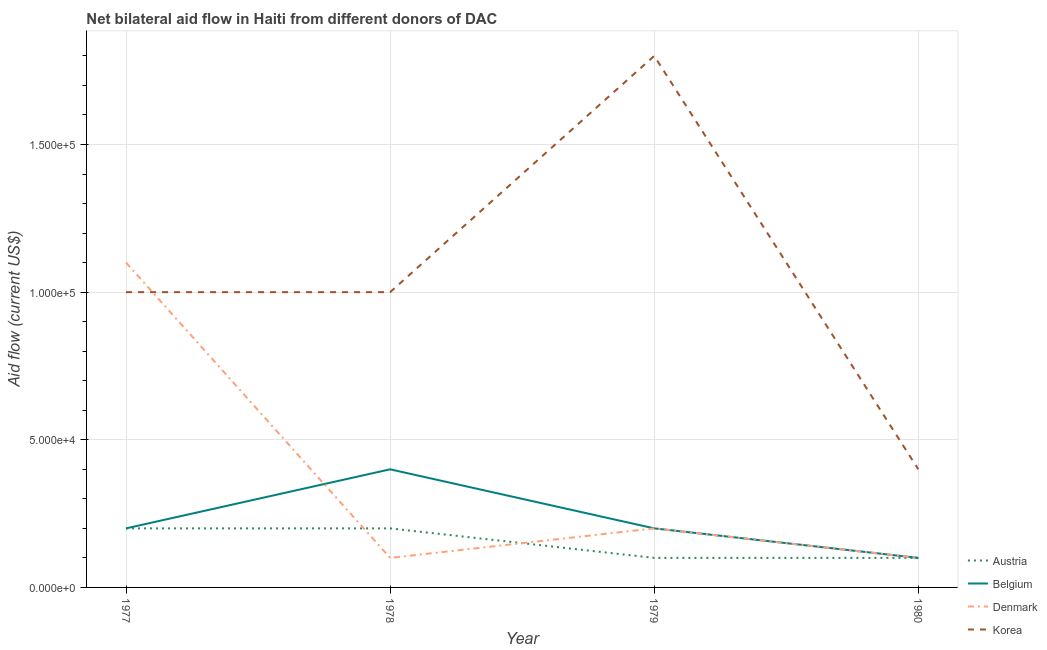Is the number of lines equal to the number of legend labels?
Keep it short and to the point. Yes. What is the amount of aid given by denmark in 1980?
Make the answer very short. 10000. Across all years, what is the maximum amount of aid given by korea?
Your response must be concise. 1.80e+05. Across all years, what is the minimum amount of aid given by korea?
Your answer should be compact. 4.00e+04. In which year was the amount of aid given by austria maximum?
Provide a short and direct response. 1977. In which year was the amount of aid given by austria minimum?
Provide a succinct answer. 1979. What is the total amount of aid given by belgium in the graph?
Keep it short and to the point. 9.00e+04. What is the difference between the amount of aid given by denmark in 1977 and that in 1980?
Your answer should be very brief. 1.00e+05. What is the difference between the amount of aid given by belgium in 1979 and the amount of aid given by denmark in 1977?
Your answer should be very brief. -9.00e+04. What is the average amount of aid given by korea per year?
Offer a terse response. 1.05e+05. In the year 1978, what is the difference between the amount of aid given by austria and amount of aid given by korea?
Your answer should be compact. -8.00e+04. In how many years, is the amount of aid given by austria greater than 120000 US$?
Offer a terse response. 0. What is the ratio of the amount of aid given by belgium in 1979 to that in 1980?
Make the answer very short. 2. Is the difference between the amount of aid given by austria in 1977 and 1979 greater than the difference between the amount of aid given by denmark in 1977 and 1979?
Keep it short and to the point. No. What is the difference between the highest and the second highest amount of aid given by austria?
Make the answer very short. 0. What is the difference between the highest and the lowest amount of aid given by austria?
Keep it short and to the point. 10000. In how many years, is the amount of aid given by austria greater than the average amount of aid given by austria taken over all years?
Your answer should be very brief. 2. Is it the case that in every year, the sum of the amount of aid given by belgium and amount of aid given by austria is greater than the sum of amount of aid given by denmark and amount of aid given by korea?
Your response must be concise. No. Does the amount of aid given by belgium monotonically increase over the years?
Keep it short and to the point. No. Is the amount of aid given by korea strictly less than the amount of aid given by austria over the years?
Keep it short and to the point. No. How many years are there in the graph?
Your response must be concise. 4. Does the graph contain grids?
Ensure brevity in your answer.  Yes. Where does the legend appear in the graph?
Provide a succinct answer. Bottom right. How are the legend labels stacked?
Keep it short and to the point. Vertical. What is the title of the graph?
Your response must be concise. Net bilateral aid flow in Haiti from different donors of DAC. What is the label or title of the X-axis?
Ensure brevity in your answer.  Year. What is the Aid flow (current US$) in Austria in 1977?
Ensure brevity in your answer.  2.00e+04. What is the Aid flow (current US$) in Belgium in 1977?
Make the answer very short. 2.00e+04. What is the Aid flow (current US$) in Denmark in 1977?
Offer a very short reply. 1.10e+05. What is the Aid flow (current US$) in Austria in 1978?
Offer a very short reply. 2.00e+04. What is the Aid flow (current US$) in Belgium in 1978?
Offer a very short reply. 4.00e+04. What is the Aid flow (current US$) of Denmark in 1978?
Make the answer very short. 10000. What is the Aid flow (current US$) of Korea in 1978?
Make the answer very short. 1.00e+05. What is the Aid flow (current US$) in Austria in 1979?
Provide a succinct answer. 10000. What is the Aid flow (current US$) of Denmark in 1979?
Offer a very short reply. 2.00e+04. What is the Aid flow (current US$) in Korea in 1979?
Provide a short and direct response. 1.80e+05. Across all years, what is the maximum Aid flow (current US$) in Belgium?
Give a very brief answer. 4.00e+04. Across all years, what is the maximum Aid flow (current US$) in Korea?
Keep it short and to the point. 1.80e+05. Across all years, what is the minimum Aid flow (current US$) in Austria?
Offer a terse response. 10000. Across all years, what is the minimum Aid flow (current US$) of Belgium?
Ensure brevity in your answer.  10000. What is the total Aid flow (current US$) in Austria in the graph?
Give a very brief answer. 6.00e+04. What is the total Aid flow (current US$) of Denmark in the graph?
Your answer should be compact. 1.50e+05. What is the total Aid flow (current US$) of Korea in the graph?
Offer a terse response. 4.20e+05. What is the difference between the Aid flow (current US$) in Austria in 1977 and that in 1978?
Offer a very short reply. 0. What is the difference between the Aid flow (current US$) of Belgium in 1977 and that in 1978?
Give a very brief answer. -2.00e+04. What is the difference between the Aid flow (current US$) in Belgium in 1977 and that in 1979?
Provide a succinct answer. 0. What is the difference between the Aid flow (current US$) in Austria in 1977 and that in 1980?
Offer a very short reply. 10000. What is the difference between the Aid flow (current US$) in Belgium in 1978 and that in 1979?
Offer a terse response. 2.00e+04. What is the difference between the Aid flow (current US$) in Korea in 1978 and that in 1979?
Give a very brief answer. -8.00e+04. What is the difference between the Aid flow (current US$) in Austria in 1978 and that in 1980?
Your answer should be very brief. 10000. What is the difference between the Aid flow (current US$) of Belgium in 1978 and that in 1980?
Give a very brief answer. 3.00e+04. What is the difference between the Aid flow (current US$) in Denmark in 1978 and that in 1980?
Keep it short and to the point. 0. What is the difference between the Aid flow (current US$) of Austria in 1979 and that in 1980?
Your answer should be compact. 0. What is the difference between the Aid flow (current US$) of Austria in 1977 and the Aid flow (current US$) of Belgium in 1978?
Offer a very short reply. -2.00e+04. What is the difference between the Aid flow (current US$) in Austria in 1977 and the Aid flow (current US$) in Denmark in 1978?
Keep it short and to the point. 10000. What is the difference between the Aid flow (current US$) of Austria in 1977 and the Aid flow (current US$) of Korea in 1978?
Keep it short and to the point. -8.00e+04. What is the difference between the Aid flow (current US$) in Belgium in 1977 and the Aid flow (current US$) in Korea in 1978?
Offer a very short reply. -8.00e+04. What is the difference between the Aid flow (current US$) in Denmark in 1977 and the Aid flow (current US$) in Korea in 1978?
Provide a short and direct response. 10000. What is the difference between the Aid flow (current US$) of Austria in 1977 and the Aid flow (current US$) of Belgium in 1979?
Your response must be concise. 0. What is the difference between the Aid flow (current US$) in Austria in 1977 and the Aid flow (current US$) in Korea in 1979?
Keep it short and to the point. -1.60e+05. What is the difference between the Aid flow (current US$) in Denmark in 1977 and the Aid flow (current US$) in Korea in 1979?
Offer a terse response. -7.00e+04. What is the difference between the Aid flow (current US$) in Austria in 1977 and the Aid flow (current US$) in Denmark in 1980?
Give a very brief answer. 10000. What is the difference between the Aid flow (current US$) of Belgium in 1977 and the Aid flow (current US$) of Korea in 1980?
Offer a terse response. -2.00e+04. What is the difference between the Aid flow (current US$) of Denmark in 1977 and the Aid flow (current US$) of Korea in 1980?
Offer a very short reply. 7.00e+04. What is the difference between the Aid flow (current US$) in Austria in 1978 and the Aid flow (current US$) in Denmark in 1979?
Offer a very short reply. 0. What is the difference between the Aid flow (current US$) in Austria in 1978 and the Aid flow (current US$) in Korea in 1979?
Give a very brief answer. -1.60e+05. What is the difference between the Aid flow (current US$) of Austria in 1978 and the Aid flow (current US$) of Denmark in 1980?
Your answer should be compact. 10000. What is the difference between the Aid flow (current US$) of Austria in 1978 and the Aid flow (current US$) of Korea in 1980?
Your answer should be compact. -2.00e+04. What is the difference between the Aid flow (current US$) in Belgium in 1978 and the Aid flow (current US$) in Denmark in 1980?
Your answer should be very brief. 3.00e+04. What is the difference between the Aid flow (current US$) in Denmark in 1978 and the Aid flow (current US$) in Korea in 1980?
Your answer should be compact. -3.00e+04. What is the difference between the Aid flow (current US$) in Austria in 1979 and the Aid flow (current US$) in Denmark in 1980?
Offer a terse response. 0. What is the average Aid flow (current US$) of Austria per year?
Provide a short and direct response. 1.50e+04. What is the average Aid flow (current US$) of Belgium per year?
Provide a succinct answer. 2.25e+04. What is the average Aid flow (current US$) of Denmark per year?
Your answer should be compact. 3.75e+04. What is the average Aid flow (current US$) of Korea per year?
Give a very brief answer. 1.05e+05. In the year 1977, what is the difference between the Aid flow (current US$) of Austria and Aid flow (current US$) of Belgium?
Your answer should be compact. 0. In the year 1977, what is the difference between the Aid flow (current US$) in Belgium and Aid flow (current US$) in Korea?
Make the answer very short. -8.00e+04. In the year 1978, what is the difference between the Aid flow (current US$) of Austria and Aid flow (current US$) of Belgium?
Your answer should be compact. -2.00e+04. In the year 1978, what is the difference between the Aid flow (current US$) of Austria and Aid flow (current US$) of Denmark?
Make the answer very short. 10000. In the year 1978, what is the difference between the Aid flow (current US$) in Austria and Aid flow (current US$) in Korea?
Your answer should be very brief. -8.00e+04. In the year 1978, what is the difference between the Aid flow (current US$) of Belgium and Aid flow (current US$) of Denmark?
Your answer should be compact. 3.00e+04. In the year 1978, what is the difference between the Aid flow (current US$) of Belgium and Aid flow (current US$) of Korea?
Your answer should be very brief. -6.00e+04. In the year 1979, what is the difference between the Aid flow (current US$) of Austria and Aid flow (current US$) of Korea?
Make the answer very short. -1.70e+05. In the year 1980, what is the difference between the Aid flow (current US$) in Austria and Aid flow (current US$) in Denmark?
Your response must be concise. 0. What is the ratio of the Aid flow (current US$) of Korea in 1977 to that in 1978?
Keep it short and to the point. 1. What is the ratio of the Aid flow (current US$) of Denmark in 1977 to that in 1979?
Make the answer very short. 5.5. What is the ratio of the Aid flow (current US$) in Korea in 1977 to that in 1979?
Offer a very short reply. 0.56. What is the ratio of the Aid flow (current US$) in Belgium in 1977 to that in 1980?
Give a very brief answer. 2. What is the ratio of the Aid flow (current US$) of Denmark in 1977 to that in 1980?
Ensure brevity in your answer.  11. What is the ratio of the Aid flow (current US$) in Belgium in 1978 to that in 1979?
Your answer should be very brief. 2. What is the ratio of the Aid flow (current US$) in Korea in 1978 to that in 1979?
Provide a short and direct response. 0.56. What is the ratio of the Aid flow (current US$) of Austria in 1978 to that in 1980?
Offer a terse response. 2. What is the ratio of the Aid flow (current US$) in Denmark in 1978 to that in 1980?
Provide a succinct answer. 1. What is the ratio of the Aid flow (current US$) of Austria in 1979 to that in 1980?
Keep it short and to the point. 1. What is the ratio of the Aid flow (current US$) of Denmark in 1979 to that in 1980?
Your answer should be compact. 2. What is the difference between the highest and the second highest Aid flow (current US$) of Austria?
Keep it short and to the point. 0. What is the difference between the highest and the second highest Aid flow (current US$) of Denmark?
Your answer should be very brief. 9.00e+04. What is the difference between the highest and the second highest Aid flow (current US$) in Korea?
Your answer should be compact. 8.00e+04. What is the difference between the highest and the lowest Aid flow (current US$) of Belgium?
Keep it short and to the point. 3.00e+04. What is the difference between the highest and the lowest Aid flow (current US$) in Korea?
Keep it short and to the point. 1.40e+05. 